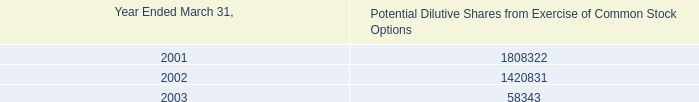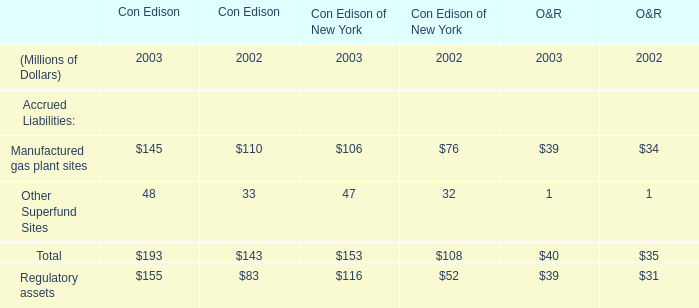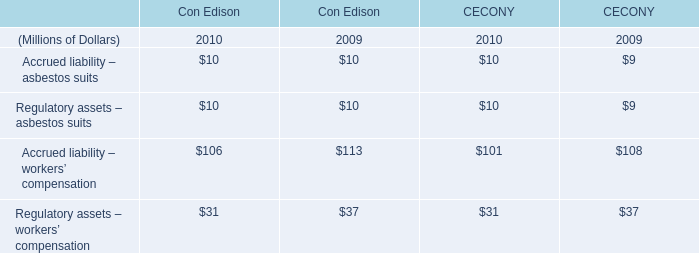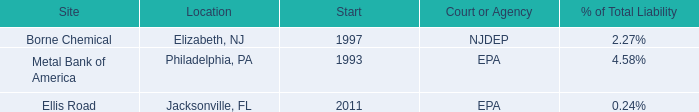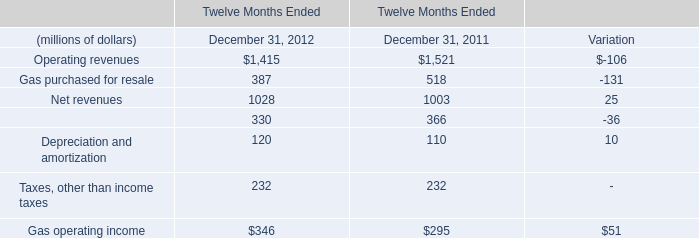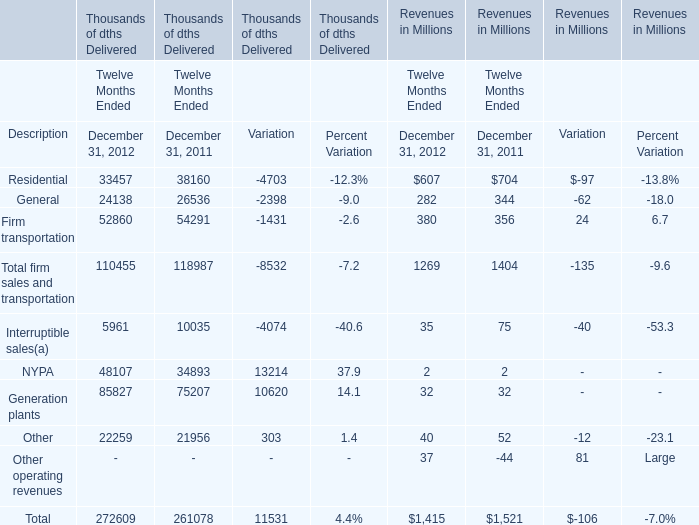what is the difference in market value of marketable securities between 2002 and 2003? 
Computations: (9858000 - 25661000)
Answer: -15803000.0. 